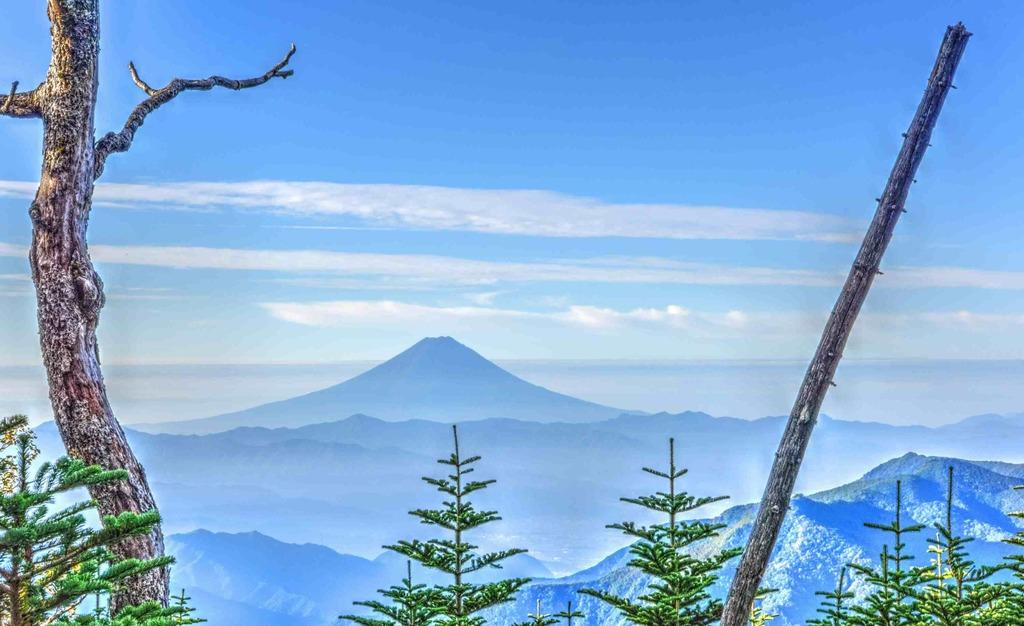What type of vegetation is present in the image? There are trees in the image. What colors can be seen on the trees? The trees have green, black, and ash colors. What can be seen in the distance behind the trees? There are mountains in the background of the image. What is visible above the trees and mountains? The sky is visible in the background of the image. What type of education is being offered by the man in the image? There is no man present in the image, and therefore no education being offered. What is the man wearing around his neck in the image? There is no man or locket present in the image. 